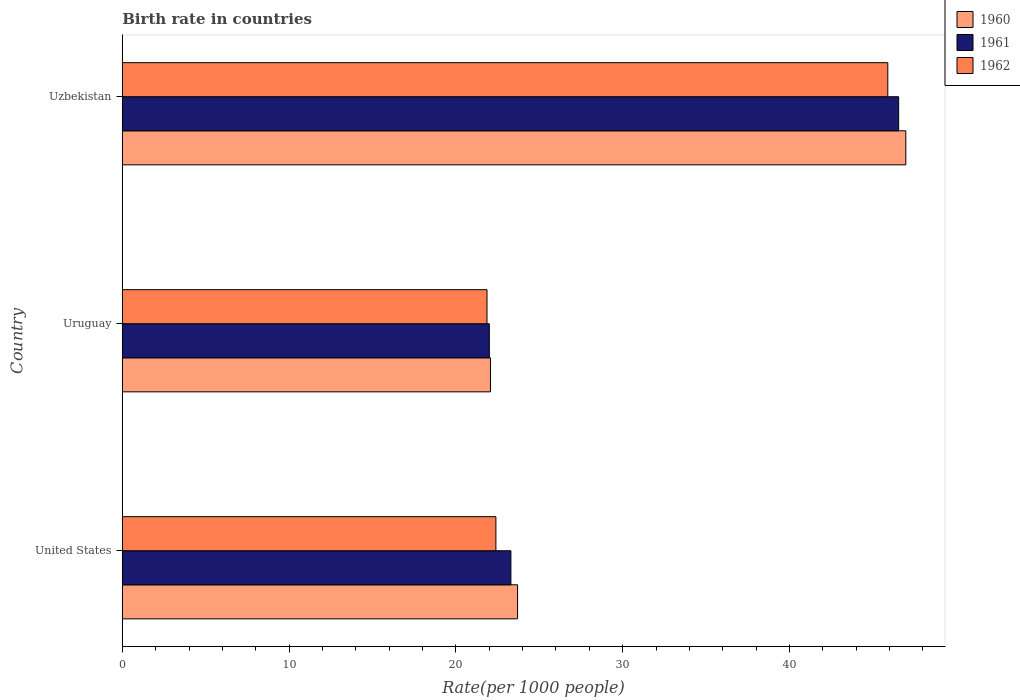How many groups of bars are there?
Offer a very short reply. 3. Are the number of bars per tick equal to the number of legend labels?
Give a very brief answer. Yes. What is the birth rate in 1961 in United States?
Ensure brevity in your answer.  23.3. Across all countries, what is the maximum birth rate in 1961?
Make the answer very short. 46.55. Across all countries, what is the minimum birth rate in 1960?
Keep it short and to the point. 22.07. In which country was the birth rate in 1962 maximum?
Keep it short and to the point. Uzbekistan. In which country was the birth rate in 1962 minimum?
Make the answer very short. Uruguay. What is the total birth rate in 1962 in the graph?
Your response must be concise. 90.16. What is the difference between the birth rate in 1960 in United States and that in Uzbekistan?
Your answer should be compact. -23.28. What is the difference between the birth rate in 1962 in United States and the birth rate in 1961 in Uruguay?
Ensure brevity in your answer.  0.39. What is the average birth rate in 1961 per country?
Give a very brief answer. 30.62. What is the difference between the birth rate in 1960 and birth rate in 1961 in Uruguay?
Your answer should be very brief. 0.07. In how many countries, is the birth rate in 1962 greater than 42 ?
Your answer should be compact. 1. What is the ratio of the birth rate in 1960 in Uruguay to that in Uzbekistan?
Provide a succinct answer. 0.47. What is the difference between the highest and the second highest birth rate in 1962?
Provide a succinct answer. 23.5. What is the difference between the highest and the lowest birth rate in 1960?
Keep it short and to the point. 24.9. Is the sum of the birth rate in 1962 in United States and Uzbekistan greater than the maximum birth rate in 1961 across all countries?
Your answer should be very brief. Yes. Is it the case that in every country, the sum of the birth rate in 1961 and birth rate in 1962 is greater than the birth rate in 1960?
Ensure brevity in your answer.  Yes. How many bars are there?
Provide a succinct answer. 9. Are all the bars in the graph horizontal?
Your answer should be compact. Yes. Are the values on the major ticks of X-axis written in scientific E-notation?
Keep it short and to the point. No. Does the graph contain grids?
Provide a short and direct response. No. How are the legend labels stacked?
Provide a short and direct response. Vertical. What is the title of the graph?
Keep it short and to the point. Birth rate in countries. Does "1970" appear as one of the legend labels in the graph?
Ensure brevity in your answer.  No. What is the label or title of the X-axis?
Your answer should be very brief. Rate(per 1000 people). What is the Rate(per 1000 people) of 1960 in United States?
Provide a short and direct response. 23.7. What is the Rate(per 1000 people) of 1961 in United States?
Offer a very short reply. 23.3. What is the Rate(per 1000 people) of 1962 in United States?
Offer a terse response. 22.4. What is the Rate(per 1000 people) of 1960 in Uruguay?
Provide a succinct answer. 22.07. What is the Rate(per 1000 people) of 1961 in Uruguay?
Offer a very short reply. 22.01. What is the Rate(per 1000 people) in 1962 in Uruguay?
Provide a succinct answer. 21.87. What is the Rate(per 1000 people) in 1960 in Uzbekistan?
Your answer should be compact. 46.98. What is the Rate(per 1000 people) of 1961 in Uzbekistan?
Your response must be concise. 46.55. What is the Rate(per 1000 people) in 1962 in Uzbekistan?
Your response must be concise. 45.9. Across all countries, what is the maximum Rate(per 1000 people) of 1960?
Provide a succinct answer. 46.98. Across all countries, what is the maximum Rate(per 1000 people) in 1961?
Your answer should be very brief. 46.55. Across all countries, what is the maximum Rate(per 1000 people) in 1962?
Ensure brevity in your answer.  45.9. Across all countries, what is the minimum Rate(per 1000 people) of 1960?
Your response must be concise. 22.07. Across all countries, what is the minimum Rate(per 1000 people) of 1961?
Offer a very short reply. 22.01. Across all countries, what is the minimum Rate(per 1000 people) in 1962?
Provide a succinct answer. 21.87. What is the total Rate(per 1000 people) in 1960 in the graph?
Give a very brief answer. 92.75. What is the total Rate(per 1000 people) of 1961 in the graph?
Provide a succinct answer. 91.86. What is the total Rate(per 1000 people) in 1962 in the graph?
Offer a terse response. 90.17. What is the difference between the Rate(per 1000 people) of 1960 in United States and that in Uruguay?
Provide a short and direct response. 1.62. What is the difference between the Rate(per 1000 people) of 1961 in United States and that in Uruguay?
Your response must be concise. 1.29. What is the difference between the Rate(per 1000 people) of 1962 in United States and that in Uruguay?
Your response must be concise. 0.53. What is the difference between the Rate(per 1000 people) of 1960 in United States and that in Uzbekistan?
Your answer should be very brief. -23.28. What is the difference between the Rate(per 1000 people) of 1961 in United States and that in Uzbekistan?
Your answer should be very brief. -23.25. What is the difference between the Rate(per 1000 people) in 1962 in United States and that in Uzbekistan?
Your answer should be compact. -23.5. What is the difference between the Rate(per 1000 people) of 1960 in Uruguay and that in Uzbekistan?
Offer a very short reply. -24.9. What is the difference between the Rate(per 1000 people) of 1961 in Uruguay and that in Uzbekistan?
Give a very brief answer. -24.54. What is the difference between the Rate(per 1000 people) of 1962 in Uruguay and that in Uzbekistan?
Your response must be concise. -24.03. What is the difference between the Rate(per 1000 people) in 1960 in United States and the Rate(per 1000 people) in 1961 in Uruguay?
Your answer should be very brief. 1.69. What is the difference between the Rate(per 1000 people) of 1960 in United States and the Rate(per 1000 people) of 1962 in Uruguay?
Ensure brevity in your answer.  1.83. What is the difference between the Rate(per 1000 people) of 1961 in United States and the Rate(per 1000 people) of 1962 in Uruguay?
Your answer should be very brief. 1.43. What is the difference between the Rate(per 1000 people) in 1960 in United States and the Rate(per 1000 people) in 1961 in Uzbekistan?
Your response must be concise. -22.85. What is the difference between the Rate(per 1000 people) of 1960 in United States and the Rate(per 1000 people) of 1962 in Uzbekistan?
Offer a very short reply. -22.2. What is the difference between the Rate(per 1000 people) of 1961 in United States and the Rate(per 1000 people) of 1962 in Uzbekistan?
Provide a short and direct response. -22.6. What is the difference between the Rate(per 1000 people) in 1960 in Uruguay and the Rate(per 1000 people) in 1961 in Uzbekistan?
Your answer should be compact. -24.47. What is the difference between the Rate(per 1000 people) in 1960 in Uruguay and the Rate(per 1000 people) in 1962 in Uzbekistan?
Ensure brevity in your answer.  -23.82. What is the difference between the Rate(per 1000 people) in 1961 in Uruguay and the Rate(per 1000 people) in 1962 in Uzbekistan?
Offer a very short reply. -23.89. What is the average Rate(per 1000 people) in 1960 per country?
Your response must be concise. 30.92. What is the average Rate(per 1000 people) of 1961 per country?
Offer a terse response. 30.62. What is the average Rate(per 1000 people) in 1962 per country?
Provide a succinct answer. 30.05. What is the difference between the Rate(per 1000 people) in 1960 and Rate(per 1000 people) in 1961 in United States?
Offer a terse response. 0.4. What is the difference between the Rate(per 1000 people) of 1960 and Rate(per 1000 people) of 1962 in United States?
Offer a terse response. 1.3. What is the difference between the Rate(per 1000 people) in 1960 and Rate(per 1000 people) in 1961 in Uruguay?
Keep it short and to the point. 0.07. What is the difference between the Rate(per 1000 people) in 1960 and Rate(per 1000 people) in 1962 in Uruguay?
Give a very brief answer. 0.21. What is the difference between the Rate(per 1000 people) in 1961 and Rate(per 1000 people) in 1962 in Uruguay?
Provide a succinct answer. 0.14. What is the difference between the Rate(per 1000 people) in 1960 and Rate(per 1000 people) in 1961 in Uzbekistan?
Give a very brief answer. 0.43. What is the difference between the Rate(per 1000 people) in 1960 and Rate(per 1000 people) in 1962 in Uzbekistan?
Ensure brevity in your answer.  1.08. What is the difference between the Rate(per 1000 people) of 1961 and Rate(per 1000 people) of 1962 in Uzbekistan?
Your answer should be compact. 0.65. What is the ratio of the Rate(per 1000 people) in 1960 in United States to that in Uruguay?
Your response must be concise. 1.07. What is the ratio of the Rate(per 1000 people) in 1961 in United States to that in Uruguay?
Keep it short and to the point. 1.06. What is the ratio of the Rate(per 1000 people) of 1962 in United States to that in Uruguay?
Offer a terse response. 1.02. What is the ratio of the Rate(per 1000 people) in 1960 in United States to that in Uzbekistan?
Your answer should be compact. 0.5. What is the ratio of the Rate(per 1000 people) of 1961 in United States to that in Uzbekistan?
Ensure brevity in your answer.  0.5. What is the ratio of the Rate(per 1000 people) in 1962 in United States to that in Uzbekistan?
Offer a very short reply. 0.49. What is the ratio of the Rate(per 1000 people) in 1960 in Uruguay to that in Uzbekistan?
Keep it short and to the point. 0.47. What is the ratio of the Rate(per 1000 people) of 1961 in Uruguay to that in Uzbekistan?
Provide a short and direct response. 0.47. What is the ratio of the Rate(per 1000 people) in 1962 in Uruguay to that in Uzbekistan?
Keep it short and to the point. 0.48. What is the difference between the highest and the second highest Rate(per 1000 people) of 1960?
Make the answer very short. 23.28. What is the difference between the highest and the second highest Rate(per 1000 people) in 1961?
Ensure brevity in your answer.  23.25. What is the difference between the highest and the second highest Rate(per 1000 people) of 1962?
Offer a terse response. 23.5. What is the difference between the highest and the lowest Rate(per 1000 people) in 1960?
Keep it short and to the point. 24.9. What is the difference between the highest and the lowest Rate(per 1000 people) of 1961?
Provide a short and direct response. 24.54. What is the difference between the highest and the lowest Rate(per 1000 people) in 1962?
Your answer should be compact. 24.03. 